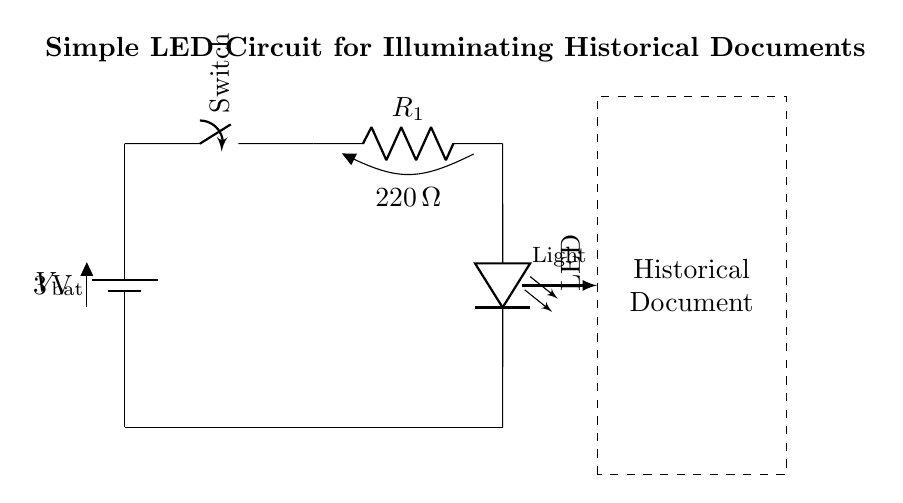What is the voltage of the battery? The voltage is indicated next to the battery symbol and is labeled as 3 volts, which represents the source voltage in the circuit.
Answer: 3 volts What is the resistance value of the resistor? The resistance value is shown next to the resistor symbol and is labeled as 220 ohms, indicating the resistor's resistance in the circuit.
Answer: 220 ohms What component is used for illumination? The component used for illumination is the LED, which is indicated in the circuit as the element that emits light when current passes through it.
Answer: LED How many components are in this circuit? The circuit consists of four main components: a battery, a switch, a resistor, and an LED. Counting these gives a total of four components.
Answer: Four What is the purpose of the switch in the circuit? The switch is used to control the flow of electricity in the circuit, allowing the user to turn the LED on or off as needed for illuminating the historical documents.
Answer: Control flow What type of circuit is represented? This is a simple series circuit, as the components are connected end to end in a single path for current flow without any branches.
Answer: Series circuit What does the dashed rectangle represent? The dashed rectangle represents the historical document that is being illuminated by the light emitted from the LED in this circuit setup.
Answer: Historical document 